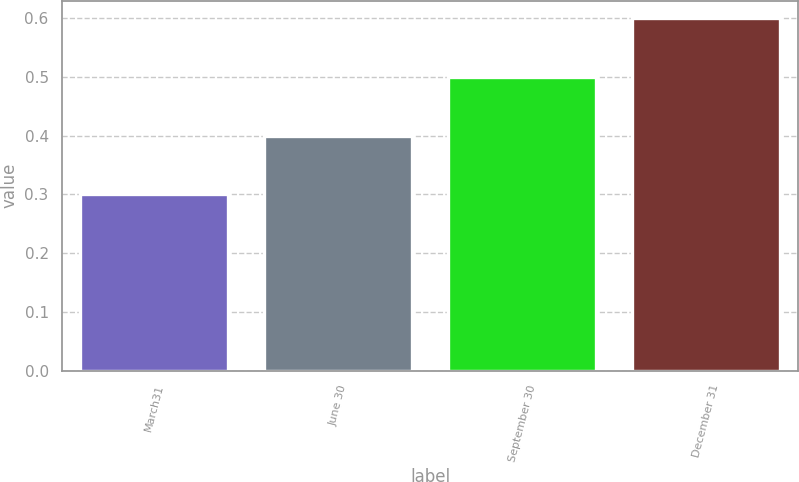Convert chart. <chart><loc_0><loc_0><loc_500><loc_500><bar_chart><fcel>March31<fcel>June 30<fcel>September 30<fcel>December 31<nl><fcel>0.3<fcel>0.4<fcel>0.5<fcel>0.6<nl></chart> 